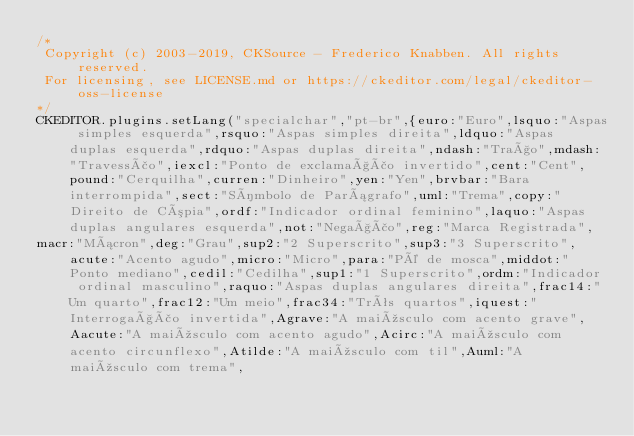<code> <loc_0><loc_0><loc_500><loc_500><_JavaScript_>/*
 Copyright (c) 2003-2019, CKSource - Frederico Knabben. All rights reserved.
 For licensing, see LICENSE.md or https://ckeditor.com/legal/ckeditor-oss-license
*/
CKEDITOR.plugins.setLang("specialchar","pt-br",{euro:"Euro",lsquo:"Aspas simples esquerda",rsquo:"Aspas simples direita",ldquo:"Aspas duplas esquerda",rdquo:"Aspas duplas direita",ndash:"Traço",mdash:"Travessão",iexcl:"Ponto de exclamação invertido",cent:"Cent",pound:"Cerquilha",curren:"Dinheiro",yen:"Yen",brvbar:"Bara interrompida",sect:"Símbolo de Parágrafo",uml:"Trema",copy:"Direito de Cópia",ordf:"Indicador ordinal feminino",laquo:"Aspas duplas angulares esquerda",not:"Negação",reg:"Marca Registrada",
macr:"Mácron",deg:"Grau",sup2:"2 Superscrito",sup3:"3 Superscrito",acute:"Acento agudo",micro:"Micro",para:"Pé de mosca",middot:"Ponto mediano",cedil:"Cedilha",sup1:"1 Superscrito",ordm:"Indicador ordinal masculino",raquo:"Aspas duplas angulares direita",frac14:"Um quarto",frac12:"Um meio",frac34:"Três quartos",iquest:"Interrogação invertida",Agrave:"A maiúsculo com acento grave",Aacute:"A maiúsculo com acento agudo",Acirc:"A maiúsculo com acento circunflexo",Atilde:"A maiúsculo com til",Auml:"A maiúsculo com trema",</code> 